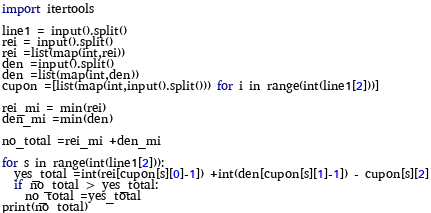<code> <loc_0><loc_0><loc_500><loc_500><_Python_>import itertools 

line1 = input().split()
rei = input().split()
rei =list(map(int,rei))
den =input().split()
den =list(map(int,den))
cupon =[list(map(int,input().split())) for i in range(int(line1[2]))]

rei_mi = min(rei)
den_mi =min(den)

no_total =rei_mi +den_mi

for s in range(int(line1[2])):
  yes_total =int(rei[cupon[s][0]-1]) +int(den[cupon[s][1]-1]) - cupon[s][2]
  if no_total > yes_total:
    no_total =yes_total
print(no_total)
</code> 